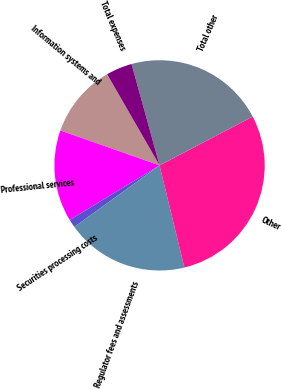Convert chart. <chart><loc_0><loc_0><loc_500><loc_500><pie_chart><fcel>Information systems and<fcel>Professional services<fcel>Securities processing costs<fcel>Regulator fees and assessments<fcel>Other<fcel>Total other<fcel>Total expenses<nl><fcel>11.31%<fcel>14.07%<fcel>1.26%<fcel>18.84%<fcel>28.89%<fcel>21.61%<fcel>4.02%<nl></chart> 